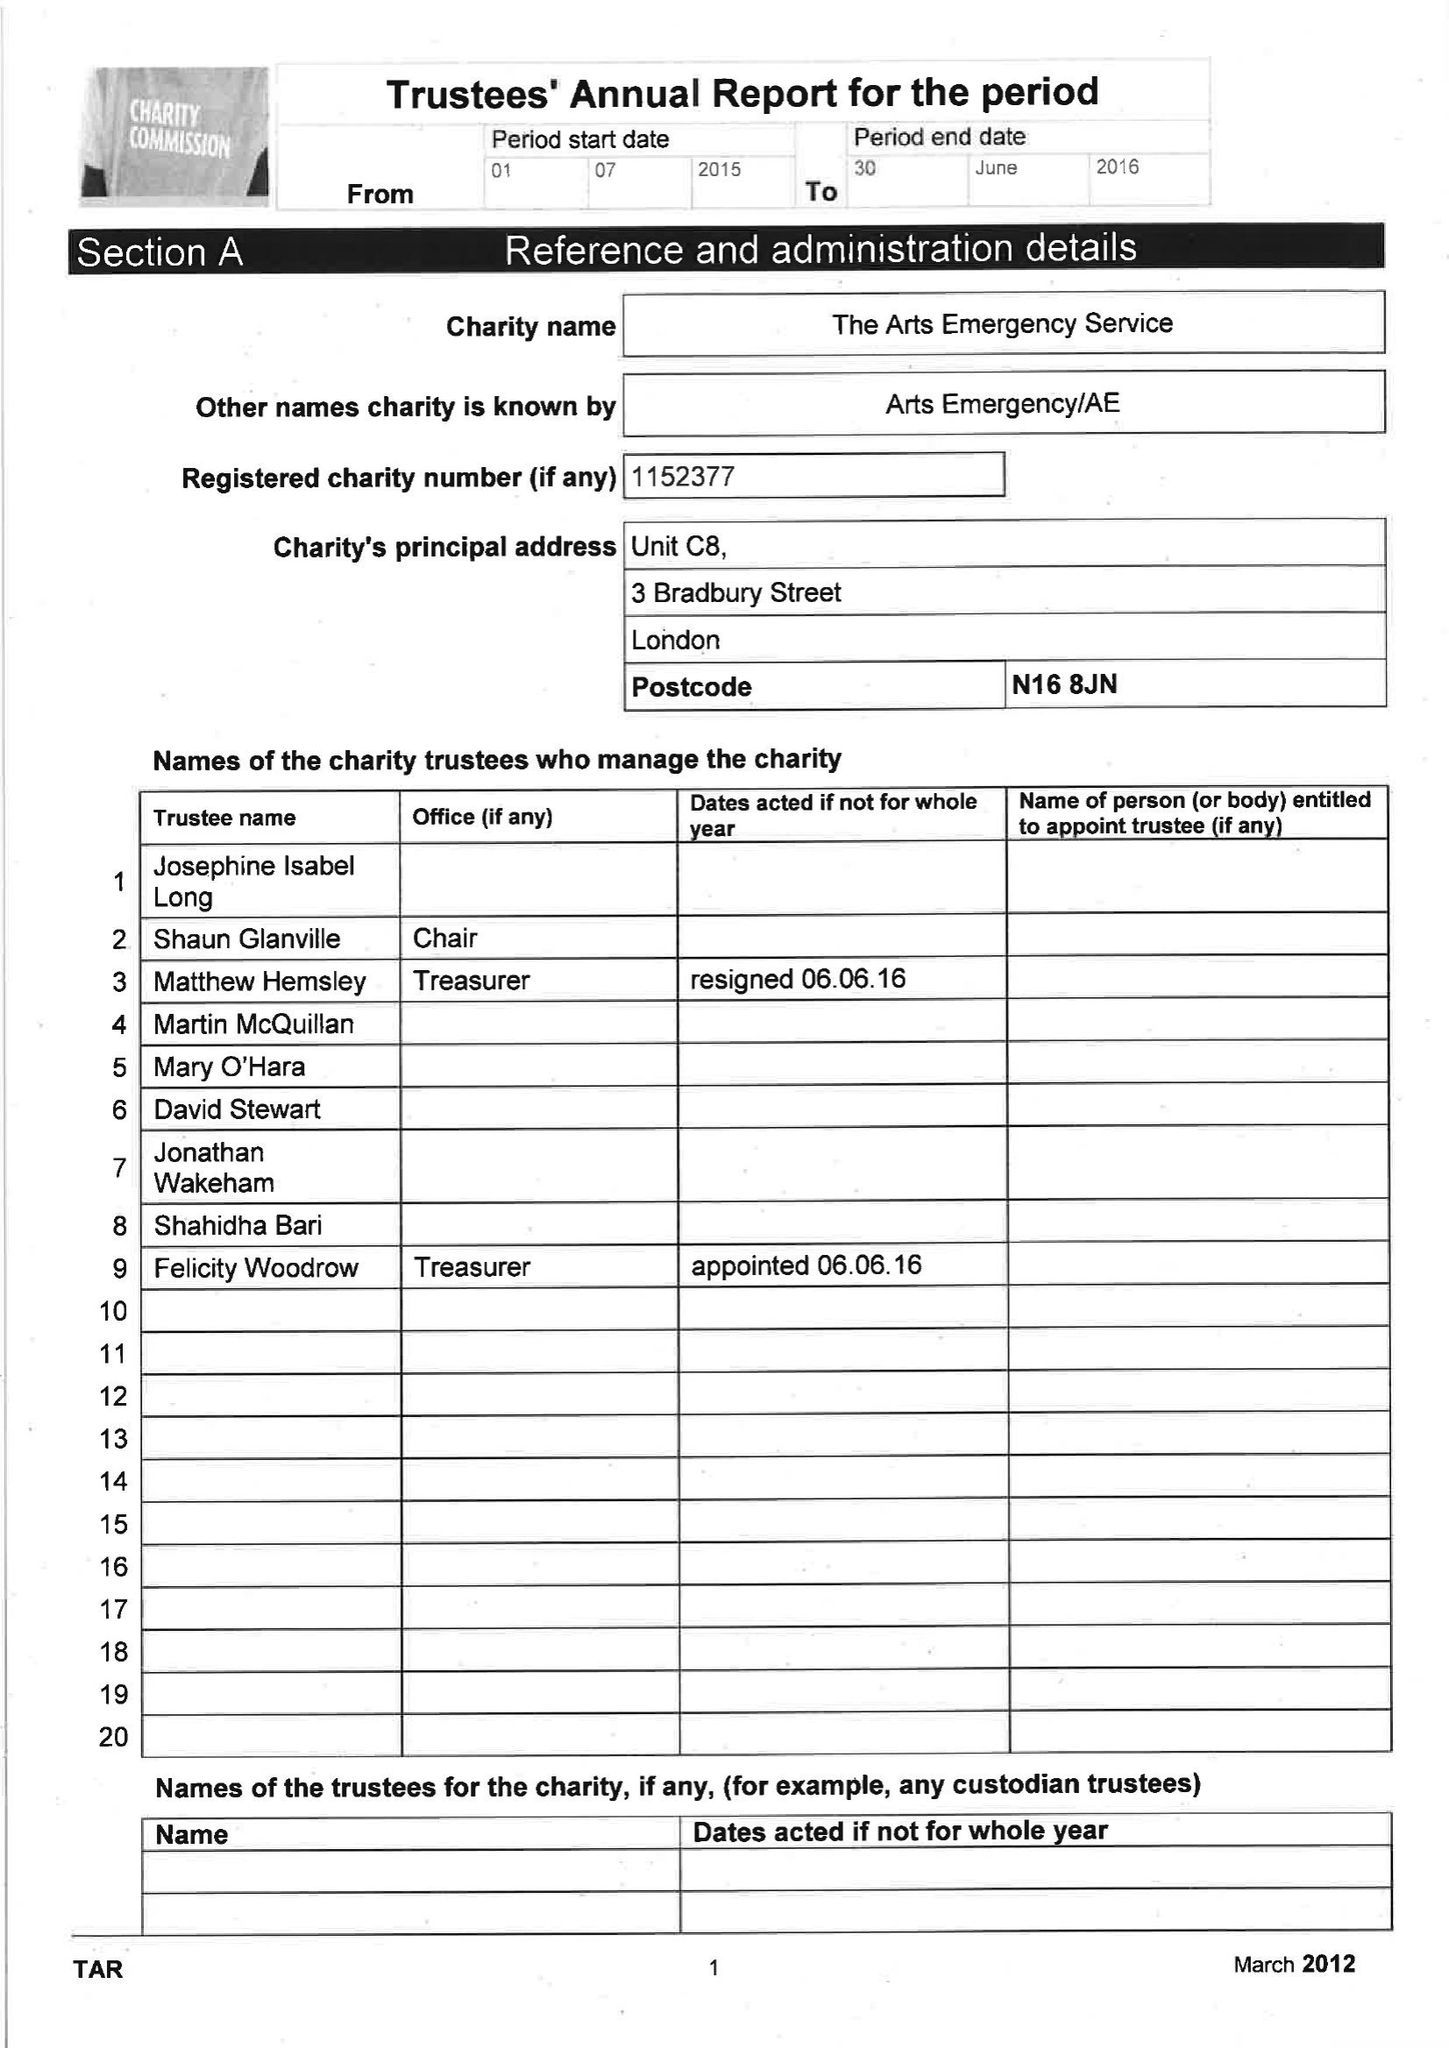What is the value for the address__street_line?
Answer the question using a single word or phrase. 8 WOODBERRY DOWN 